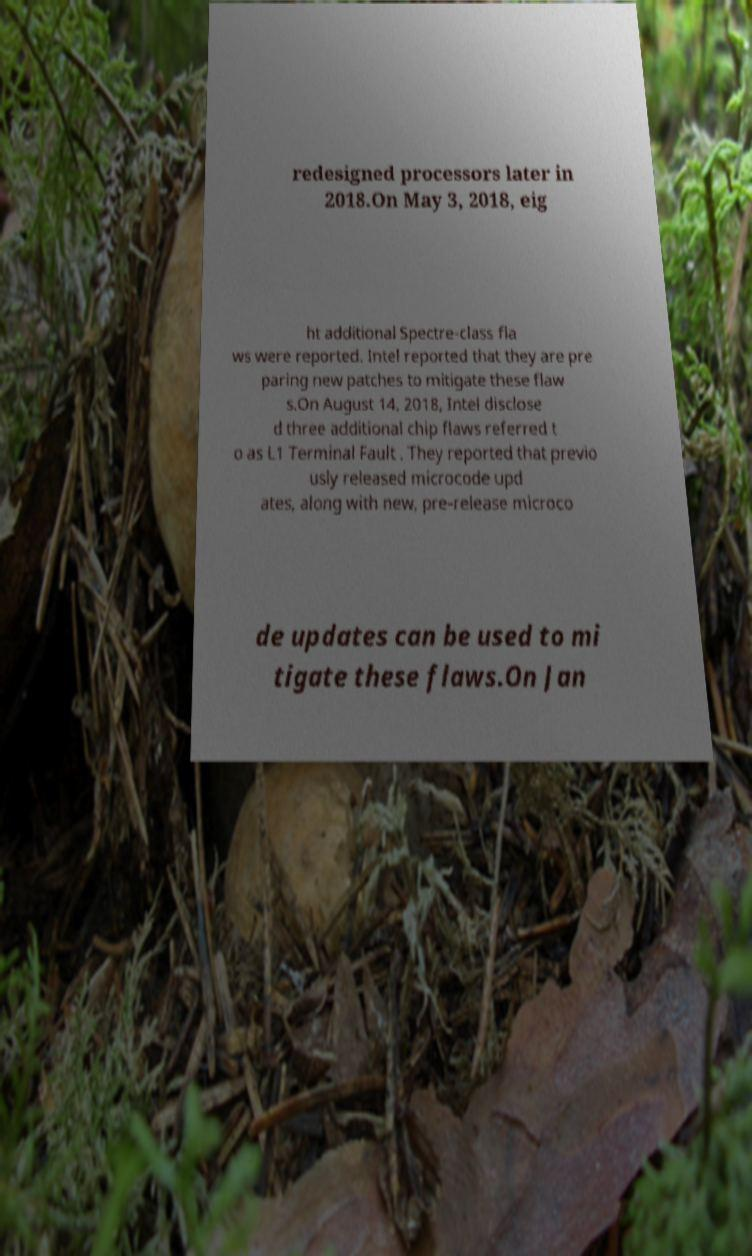I need the written content from this picture converted into text. Can you do that? redesigned processors later in 2018.On May 3, 2018, eig ht additional Spectre-class fla ws were reported. Intel reported that they are pre paring new patches to mitigate these flaw s.On August 14, 2018, Intel disclose d three additional chip flaws referred t o as L1 Terminal Fault . They reported that previo usly released microcode upd ates, along with new, pre-release microco de updates can be used to mi tigate these flaws.On Jan 